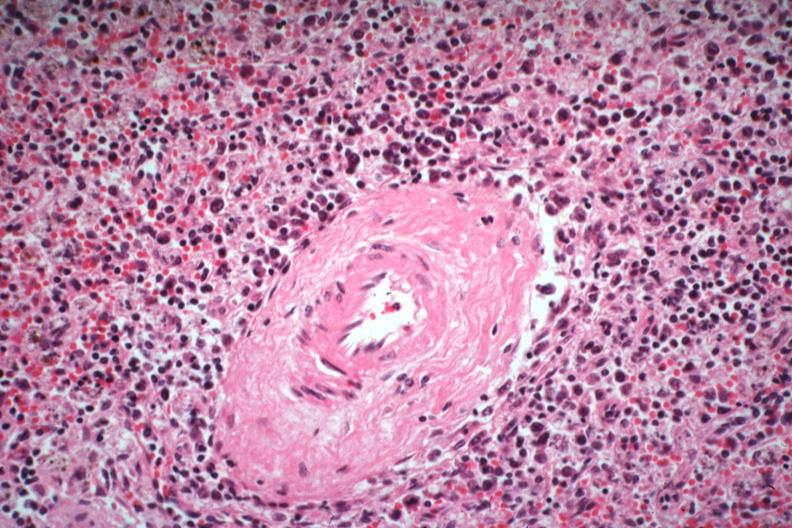what is present?
Answer the question using a single word or phrase. Immunoblastic reaction characteristic of viral infection 